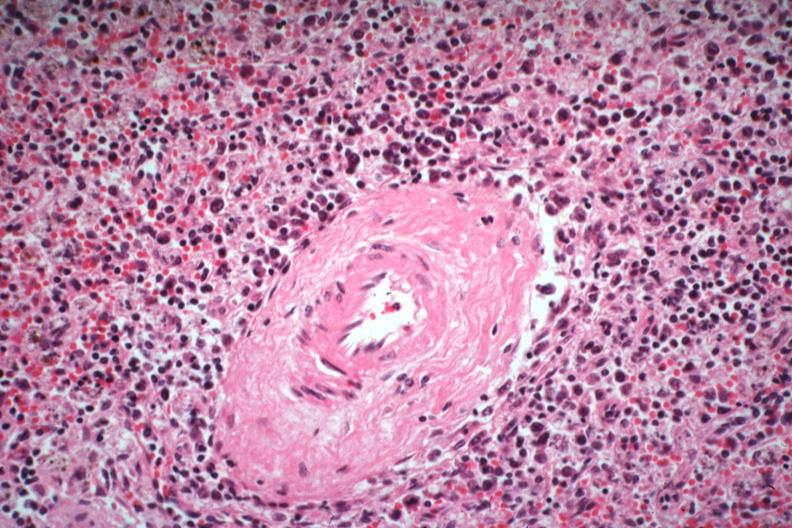what is present?
Answer the question using a single word or phrase. Immunoblastic reaction characteristic of viral infection 